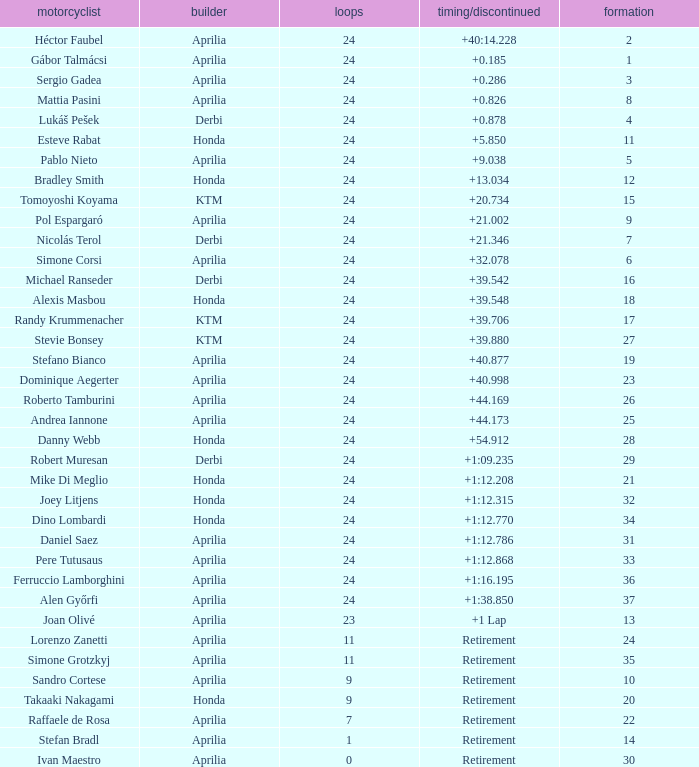Who manufactured the motorcycle that did 24 laps and 9 grids? Aprilia. 